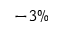Convert formula to latex. <formula><loc_0><loc_0><loc_500><loc_500>- 3 \%</formula> 